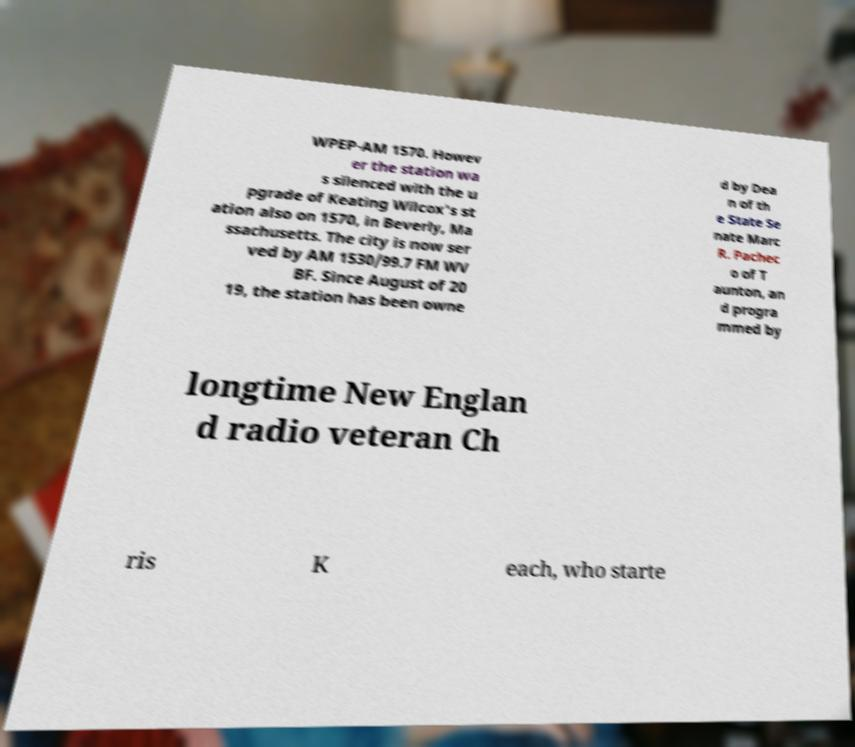There's text embedded in this image that I need extracted. Can you transcribe it verbatim? WPEP-AM 1570. Howev er the station wa s silenced with the u pgrade of Keating Wilcox's st ation also on 1570, in Beverly, Ma ssachusetts. The city is now ser ved by AM 1530/99.7 FM WV BF. Since August of 20 19, the station has been owne d by Dea n of th e State Se nate Marc R. Pachec o of T aunton, an d progra mmed by longtime New Englan d radio veteran Ch ris K each, who starte 